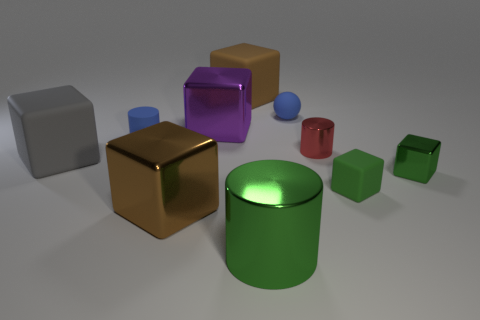What is the shape of the brown thing that is the same material as the large purple cube? The brown object that shares the same reflective glossy material as the large purple cube is also a cube. This is evident from its geometric properties: it has six faces, each of which is a square, and each of its vertices meets three faces at right angles, which is characteristic of a cube. 